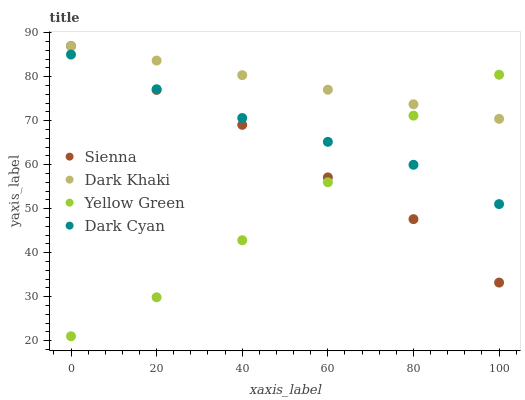Does Yellow Green have the minimum area under the curve?
Answer yes or no. Yes. Does Dark Khaki have the maximum area under the curve?
Answer yes or no. Yes. Does Dark Khaki have the minimum area under the curve?
Answer yes or no. No. Does Yellow Green have the maximum area under the curve?
Answer yes or no. No. Is Dark Khaki the smoothest?
Answer yes or no. Yes. Is Sienna the roughest?
Answer yes or no. Yes. Is Yellow Green the smoothest?
Answer yes or no. No. Is Yellow Green the roughest?
Answer yes or no. No. Does Yellow Green have the lowest value?
Answer yes or no. Yes. Does Dark Khaki have the lowest value?
Answer yes or no. No. Does Dark Khaki have the highest value?
Answer yes or no. Yes. Does Yellow Green have the highest value?
Answer yes or no. No. Is Dark Cyan less than Dark Khaki?
Answer yes or no. Yes. Is Dark Khaki greater than Dark Cyan?
Answer yes or no. Yes. Does Yellow Green intersect Dark Khaki?
Answer yes or no. Yes. Is Yellow Green less than Dark Khaki?
Answer yes or no. No. Is Yellow Green greater than Dark Khaki?
Answer yes or no. No. Does Dark Cyan intersect Dark Khaki?
Answer yes or no. No. 